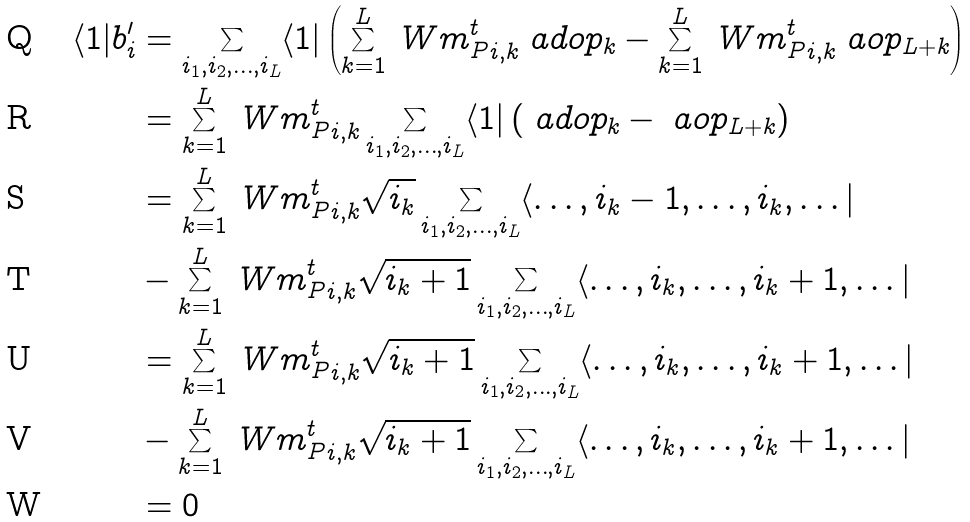<formula> <loc_0><loc_0><loc_500><loc_500>\langle 1 | b _ { i } ^ { \prime } & = \sum _ { i _ { 1 } , i _ { 2 } , \dots , i _ { L } } \langle 1 | \left ( \sum _ { k = 1 } ^ { L } { \ W m _ { P } ^ { t } } _ { i , k } \ a d o p _ { k } - \sum _ { k = 1 } ^ { L } { \ W m _ { P } ^ { t } } _ { i , k } \ a o p _ { L + k } \right ) \\ & = \sum _ { k = 1 } ^ { L } { \ W m _ { P } ^ { t } } _ { i , k } \sum _ { i _ { 1 } , i _ { 2 } , \dots , i _ { L } } \langle 1 | \left ( \ a d o p _ { k } - \ a o p _ { L + k } \right ) \\ & = \sum _ { k = 1 } ^ { L } { \ W m _ { P } ^ { t } } _ { i , k } \sqrt { i _ { k } } \sum _ { i _ { 1 } , i _ { 2 } , \dots , i _ { L } } \langle \dots , i _ { k } - 1 , \dots , i _ { k } , \dots | \\ & - \sum _ { k = 1 } ^ { L } { \ W m _ { P } ^ { t } } _ { i , k } \sqrt { i _ { k } + 1 } \sum _ { i _ { 1 } , i _ { 2 } , \dots , i _ { L } } \langle \dots , i _ { k } , \dots , i _ { k } + 1 , \dots | \\ & = \sum _ { k = 1 } ^ { L } { \ W m _ { P } ^ { t } } _ { i , k } \sqrt { i _ { k } + 1 } \sum _ { i _ { 1 } , i _ { 2 } , \dots , i _ { L } } \langle \dots , i _ { k } , \dots , i _ { k } + 1 , \dots | \\ & - \sum _ { k = 1 } ^ { L } { \ W m _ { P } ^ { t } } _ { i , k } \sqrt { i _ { k } + 1 } \sum _ { i _ { 1 } , i _ { 2 } , \dots , i _ { L } } \langle \dots , i _ { k } , \dots , i _ { k } + 1 , \dots | \\ & = 0</formula> 